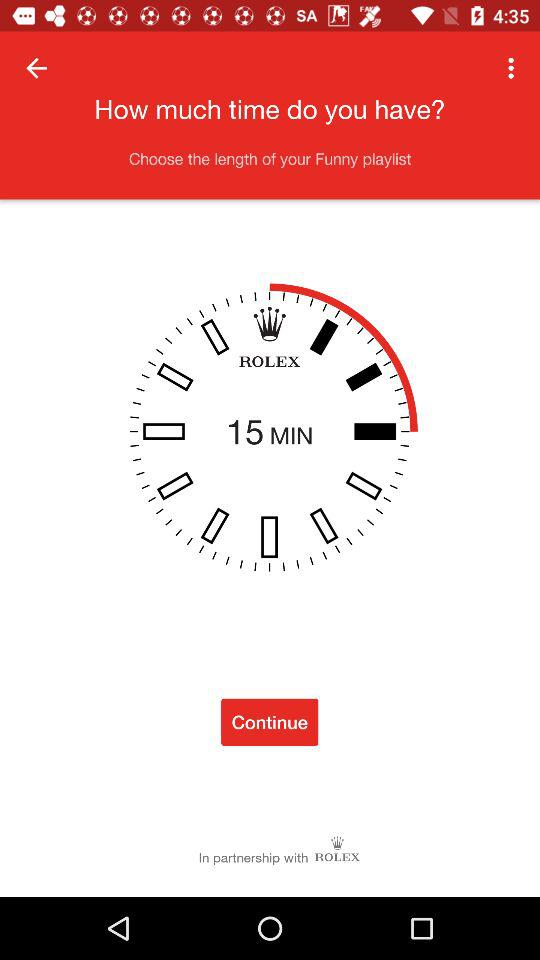Which files are included in the funny playlist?
When the provided information is insufficient, respond with <no answer>. <no answer> 